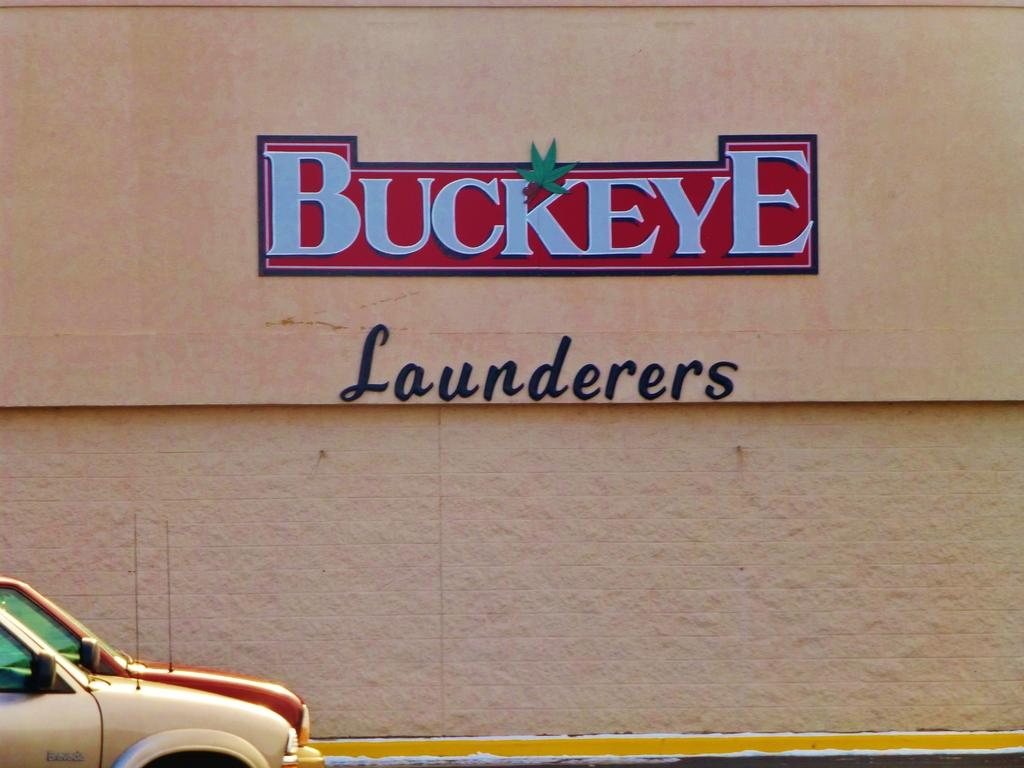What type of vehicles are located at the bottom left of the image? There are cars at the bottom left of the image. What can be seen in the middle of the image? There is text on the walls of a building in the middle of the image. What color is the grape that is levitating in the image? There is no grape present in the image, and even if there were, it would not be levitating. What type of magic is being performed in the image? There is no magic or magical elements present in the image. 